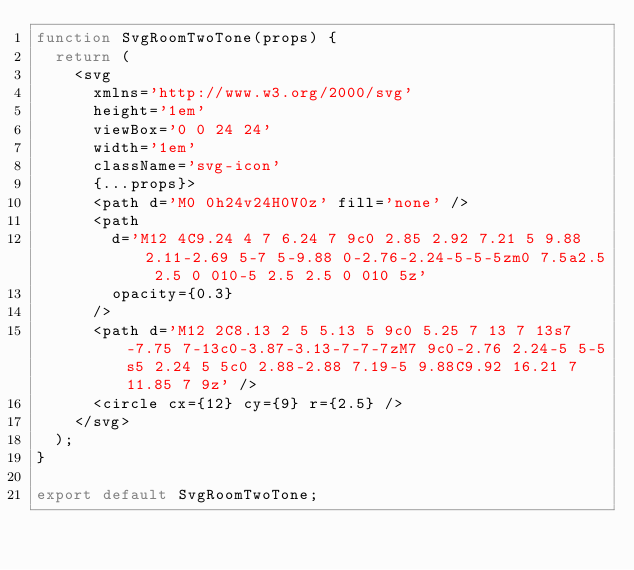Convert code to text. <code><loc_0><loc_0><loc_500><loc_500><_JavaScript_>function SvgRoomTwoTone(props) {
	return (
		<svg
			xmlns='http://www.w3.org/2000/svg'
			height='1em'
			viewBox='0 0 24 24'
			width='1em'
			className='svg-icon'
			{...props}>
			<path d='M0 0h24v24H0V0z' fill='none' />
			<path
				d='M12 4C9.24 4 7 6.24 7 9c0 2.85 2.92 7.21 5 9.88 2.11-2.69 5-7 5-9.88 0-2.76-2.24-5-5-5zm0 7.5a2.5 2.5 0 010-5 2.5 2.5 0 010 5z'
				opacity={0.3}
			/>
			<path d='M12 2C8.13 2 5 5.13 5 9c0 5.25 7 13 7 13s7-7.75 7-13c0-3.87-3.13-7-7-7zM7 9c0-2.76 2.24-5 5-5s5 2.24 5 5c0 2.88-2.88 7.19-5 9.88C9.92 16.21 7 11.85 7 9z' />
			<circle cx={12} cy={9} r={2.5} />
		</svg>
	);
}

export default SvgRoomTwoTone;
</code> 